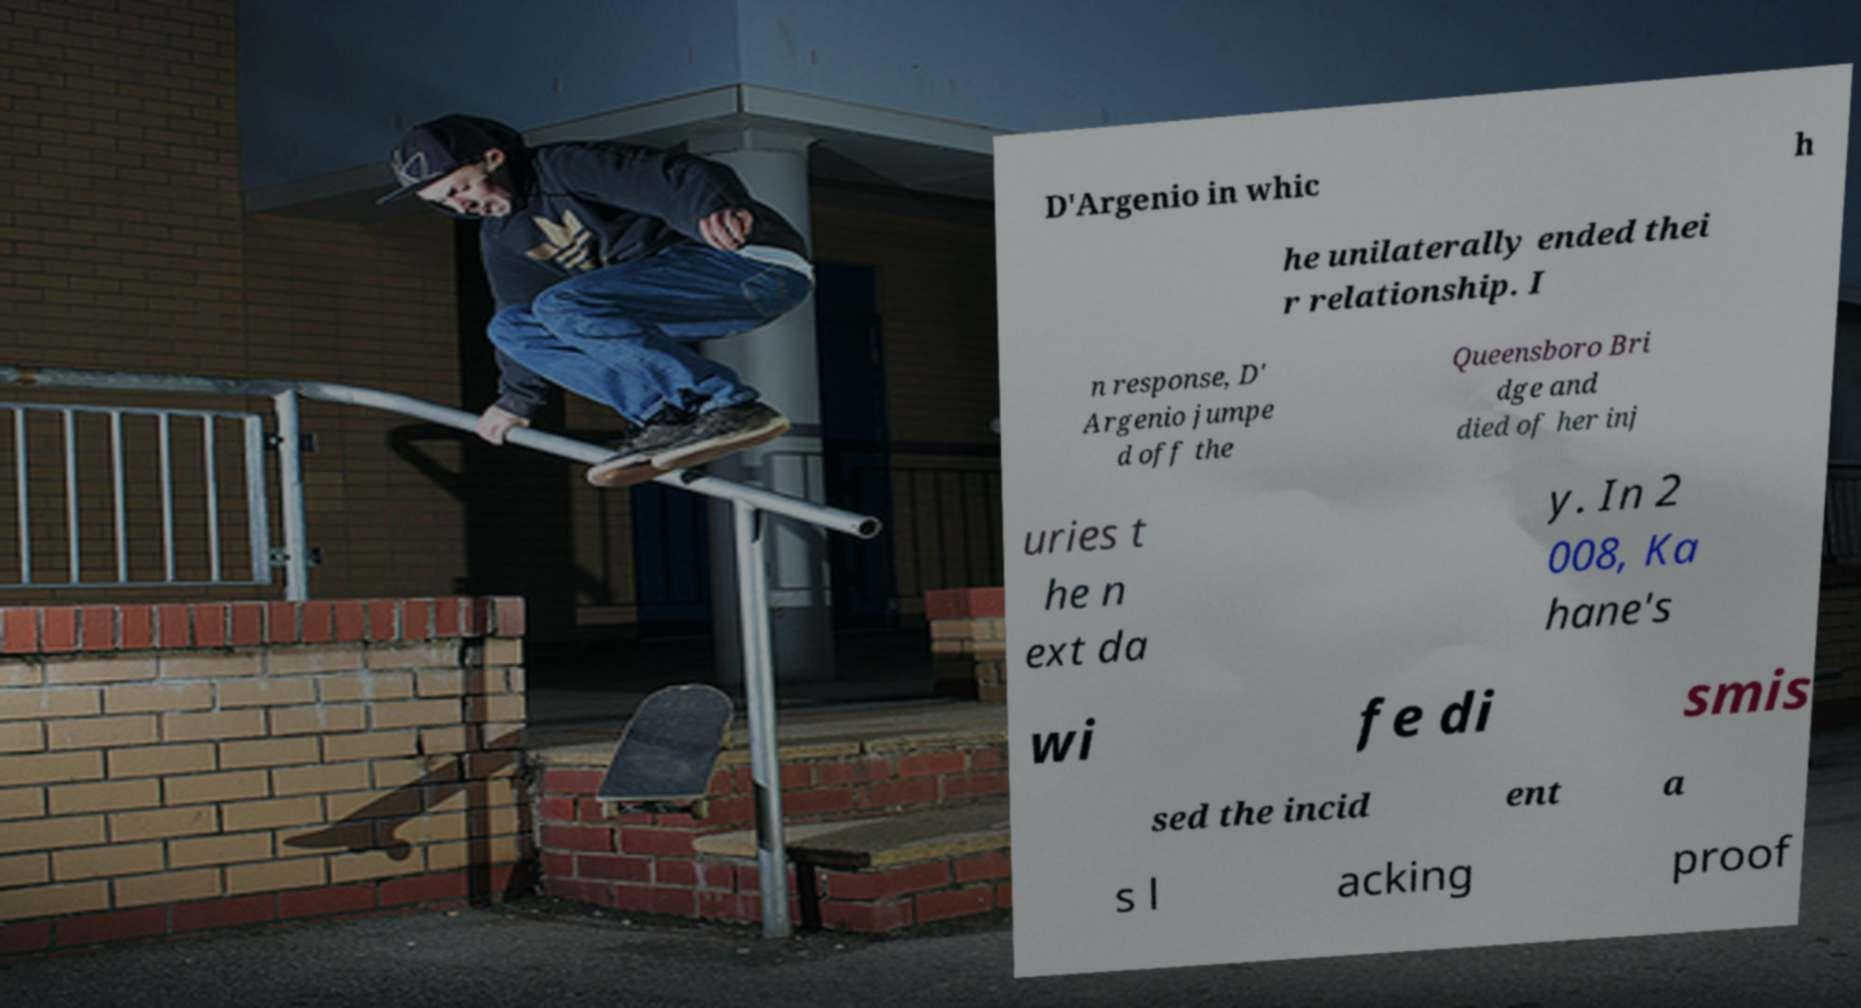Can you read and provide the text displayed in the image?This photo seems to have some interesting text. Can you extract and type it out for me? D'Argenio in whic h he unilaterally ended thei r relationship. I n response, D' Argenio jumpe d off the Queensboro Bri dge and died of her inj uries t he n ext da y. In 2 008, Ka hane's wi fe di smis sed the incid ent a s l acking proof 